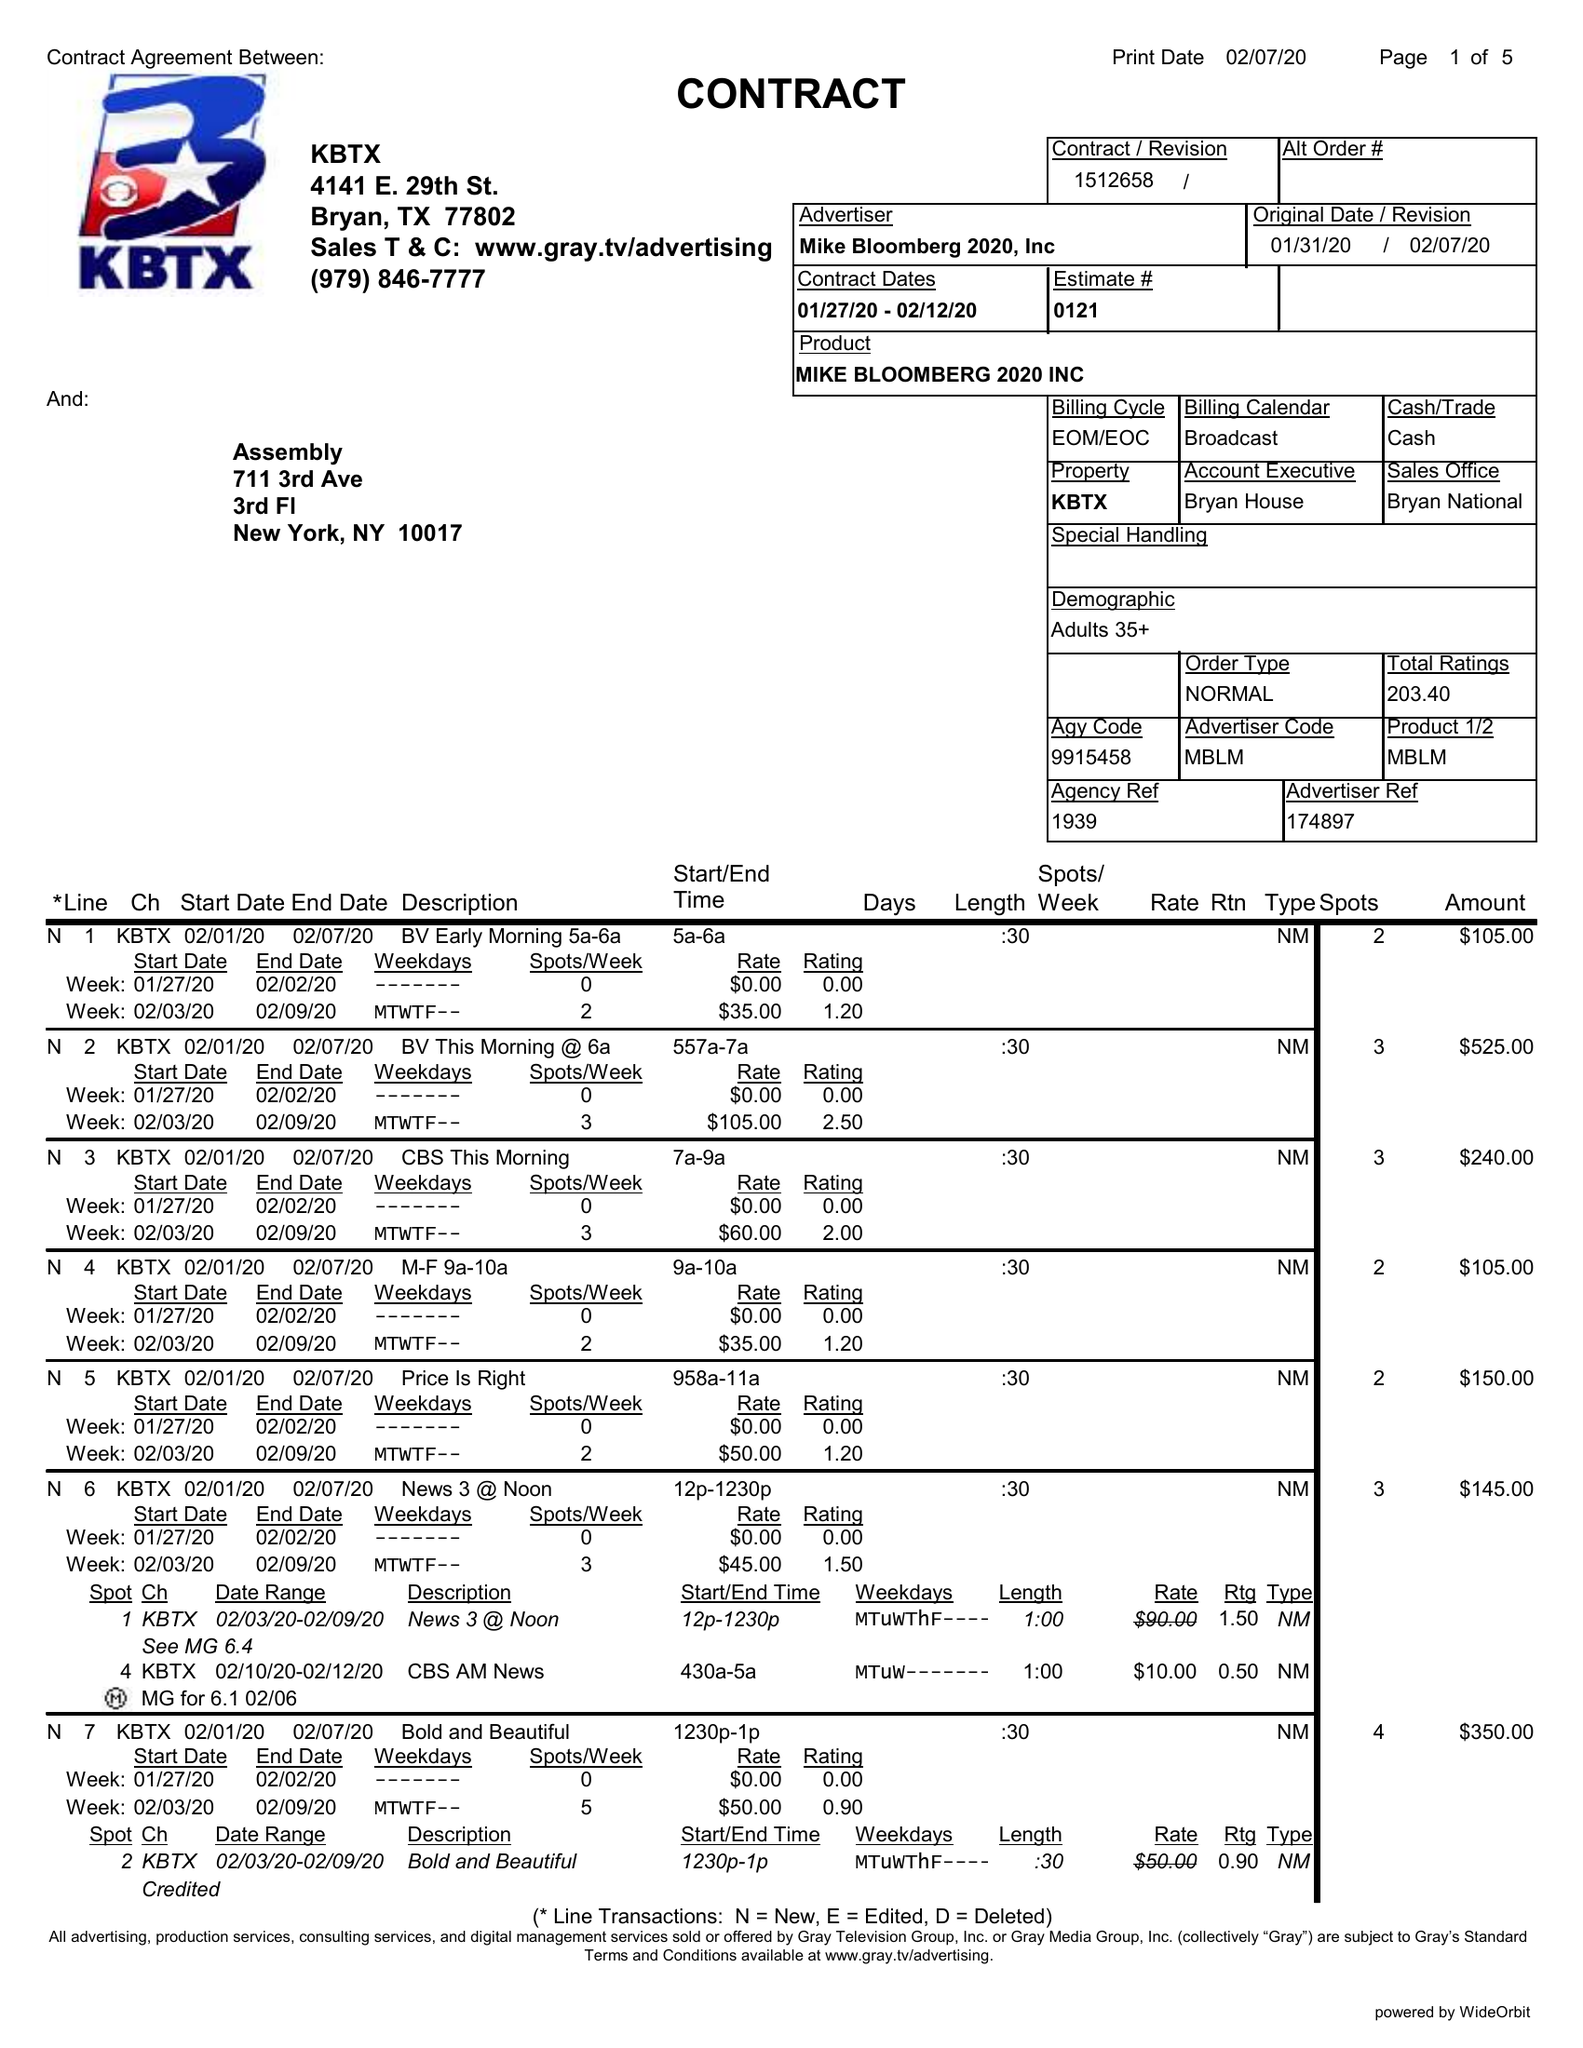What is the value for the flight_from?
Answer the question using a single word or phrase. 01/27/20 